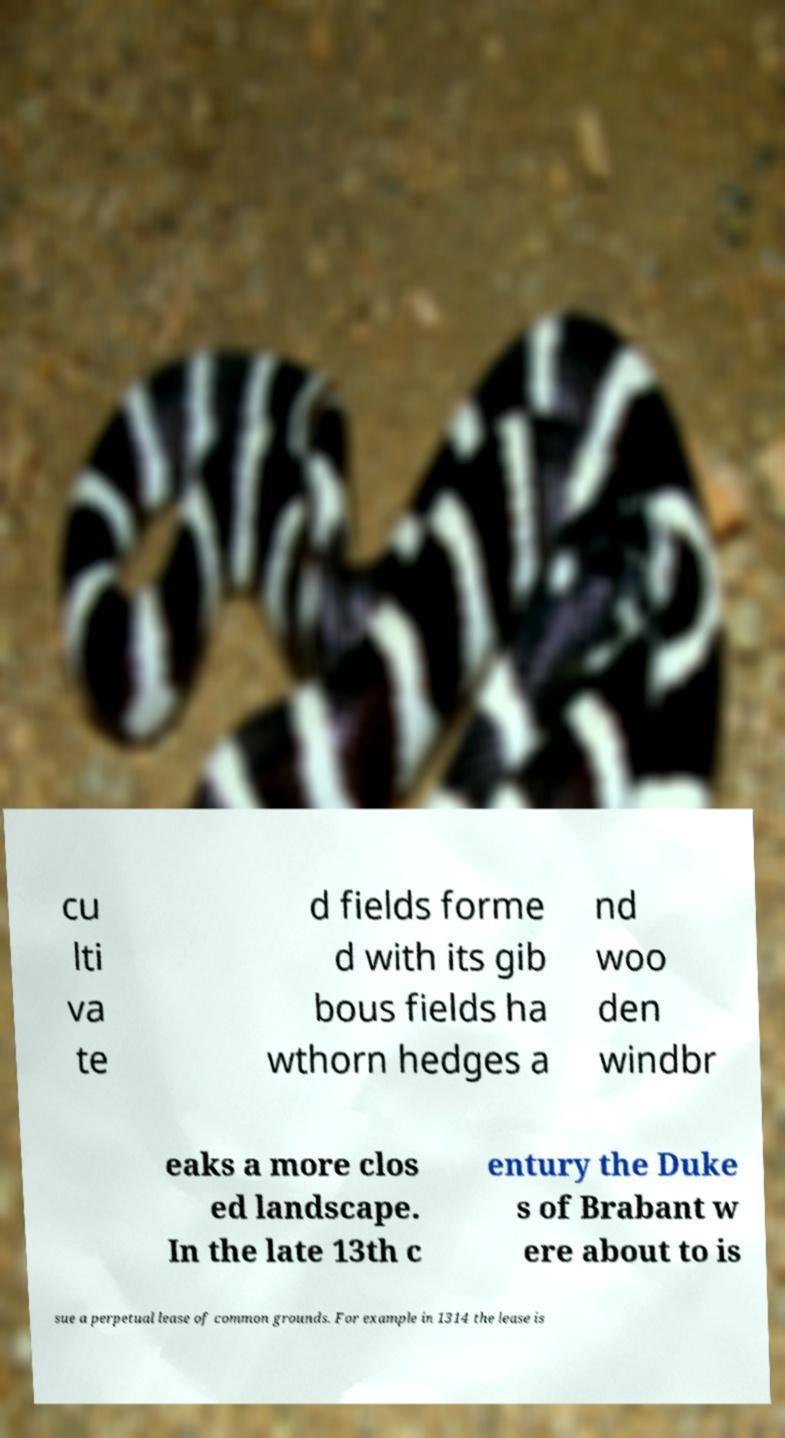Can you accurately transcribe the text from the provided image for me? cu lti va te d fields forme d with its gib bous fields ha wthorn hedges a nd woo den windbr eaks a more clos ed landscape. In the late 13th c entury the Duke s of Brabant w ere about to is sue a perpetual lease of common grounds. For example in 1314 the lease is 